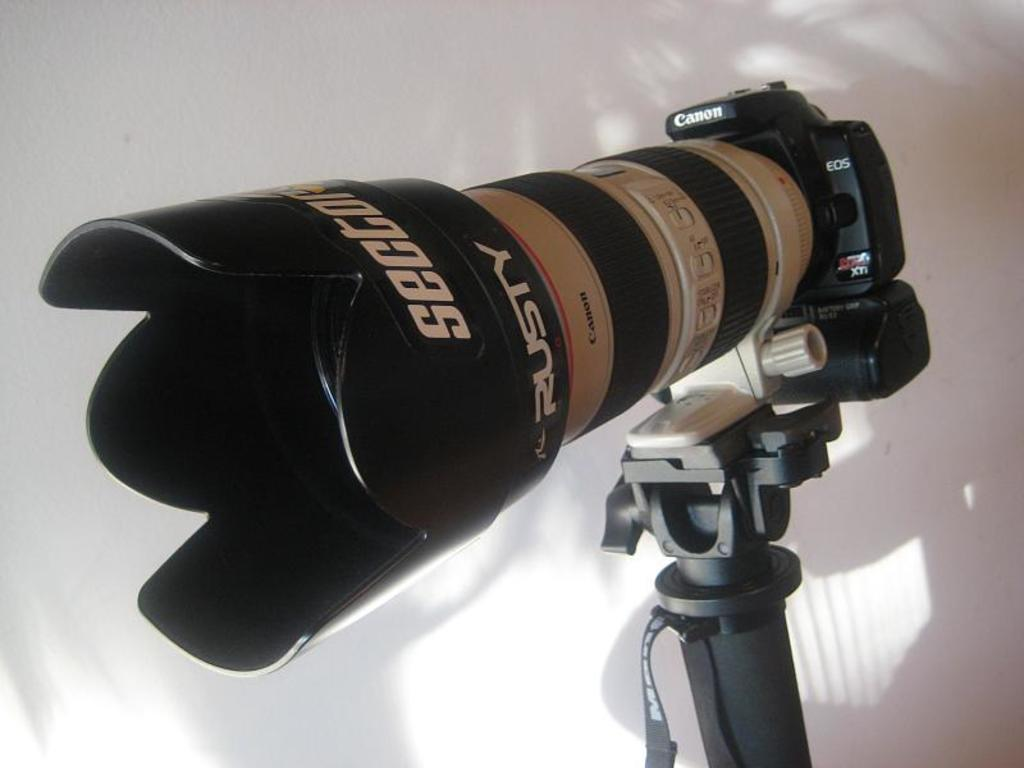What is the main object in the image? There is a camera in the image. How is the camera positioned in the image? The camera has a stand in the image. What can be seen in the background of the image? There is a wall in the background of the image. How many lizards are sitting on the furniture in the image? There are no lizards or furniture present in the image; it only features a camera with a stand and a wall in the background. 